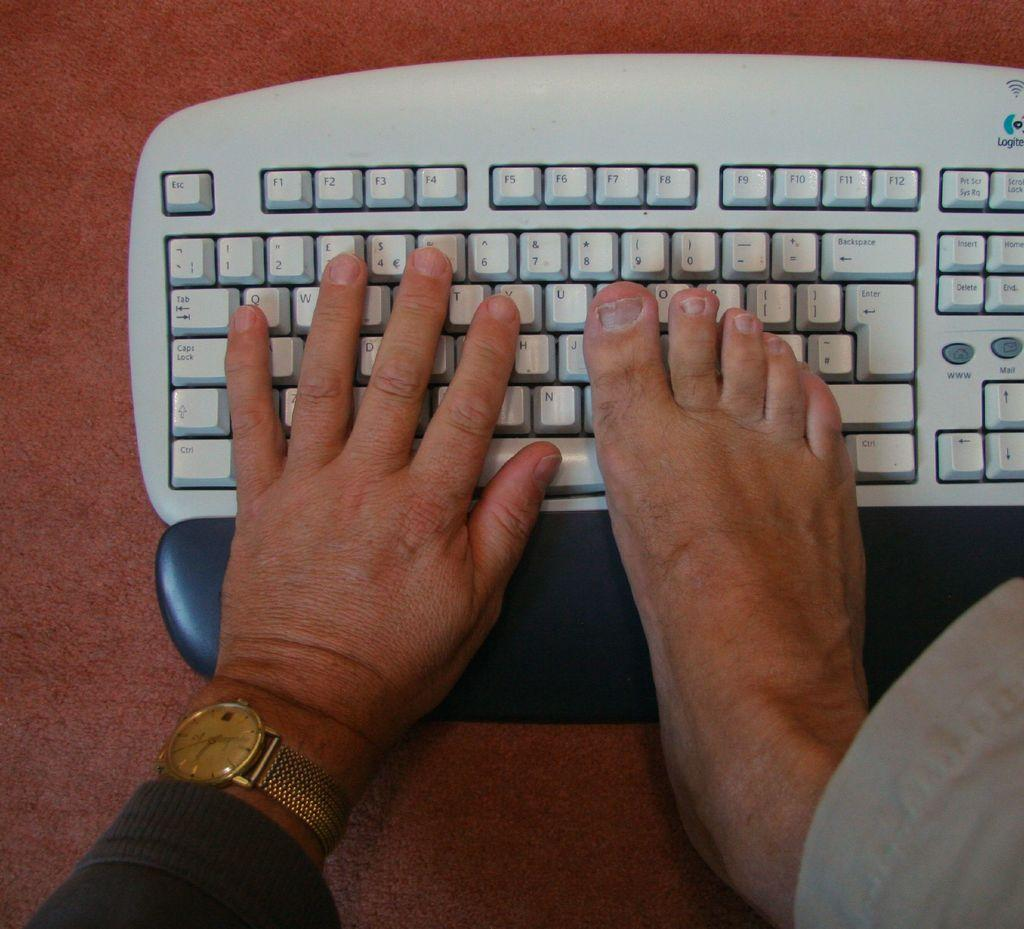<image>
Give a short and clear explanation of the subsequent image. A hand and a foot are on a qwerty keyboard. 